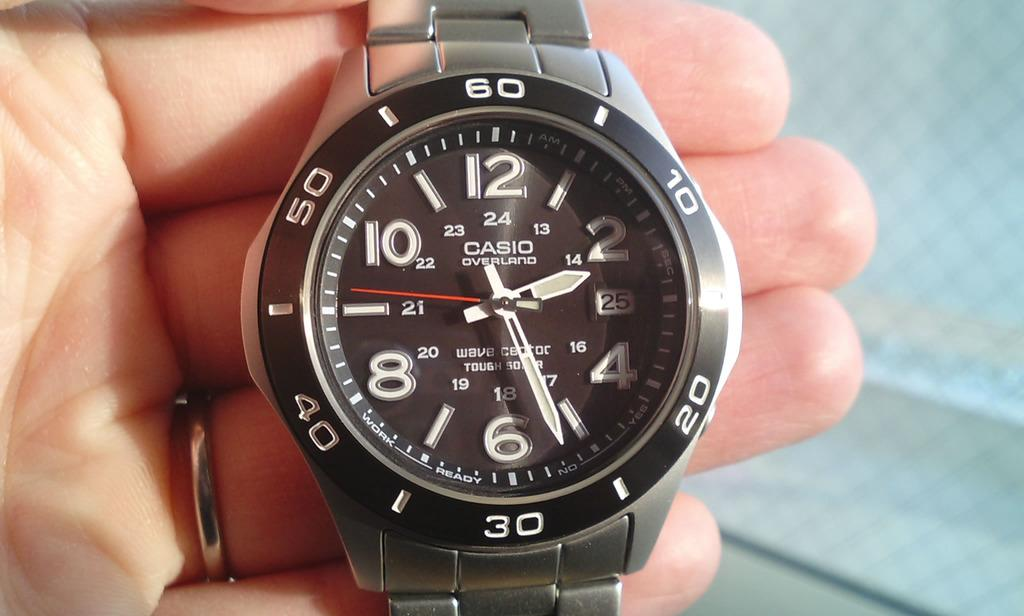<image>
Relay a brief, clear account of the picture shown. A casio overland watch face with large numbers is held in a hand. 